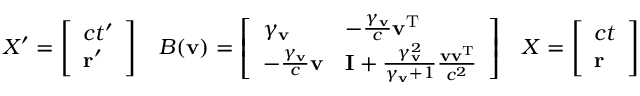<formula> <loc_0><loc_0><loc_500><loc_500>X ^ { \prime } = { \left [ \begin{array} { l } { c t ^ { \prime } } \\ { r ^ { \prime } } \end{array} \right ] } \quad B ( v ) = { \left [ \begin{array} { l l } { \gamma _ { v } } & { - { \frac { \gamma _ { v } } { c } } v ^ { T } } \\ { - { \frac { \gamma _ { v } } { c } } v } & { I + { \frac { \gamma _ { v } ^ { 2 } } { \gamma _ { v } + 1 } } { \frac { v v ^ { T } } { c ^ { 2 } } } } \end{array} \right ] } \quad X = { \left [ \begin{array} { l } { c t } \\ { r } \end{array} \right ] }</formula> 